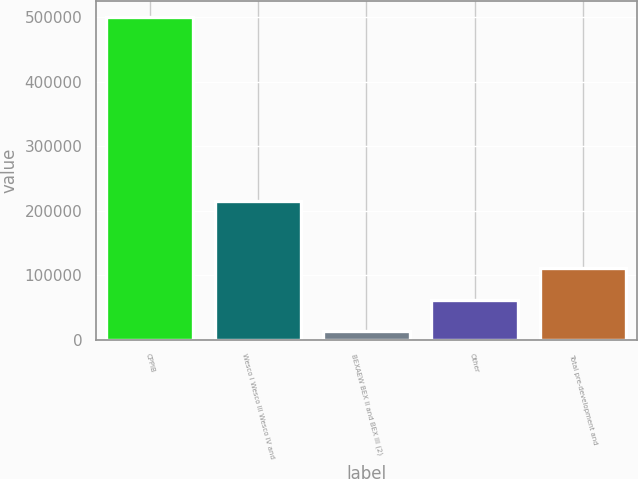<chart> <loc_0><loc_0><loc_500><loc_500><bar_chart><fcel>CPPIB<fcel>Wesco I Wesco III Wesco IV and<fcel>BEXAEW BEX II and BEX III (2)<fcel>Other<fcel>Total pre-development and<nl><fcel>500287<fcel>214408<fcel>13827<fcel>62473<fcel>111119<nl></chart> 